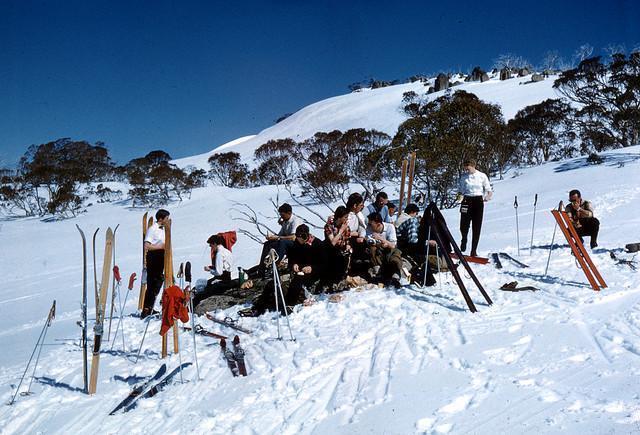How many people are there?
Give a very brief answer. 2. 